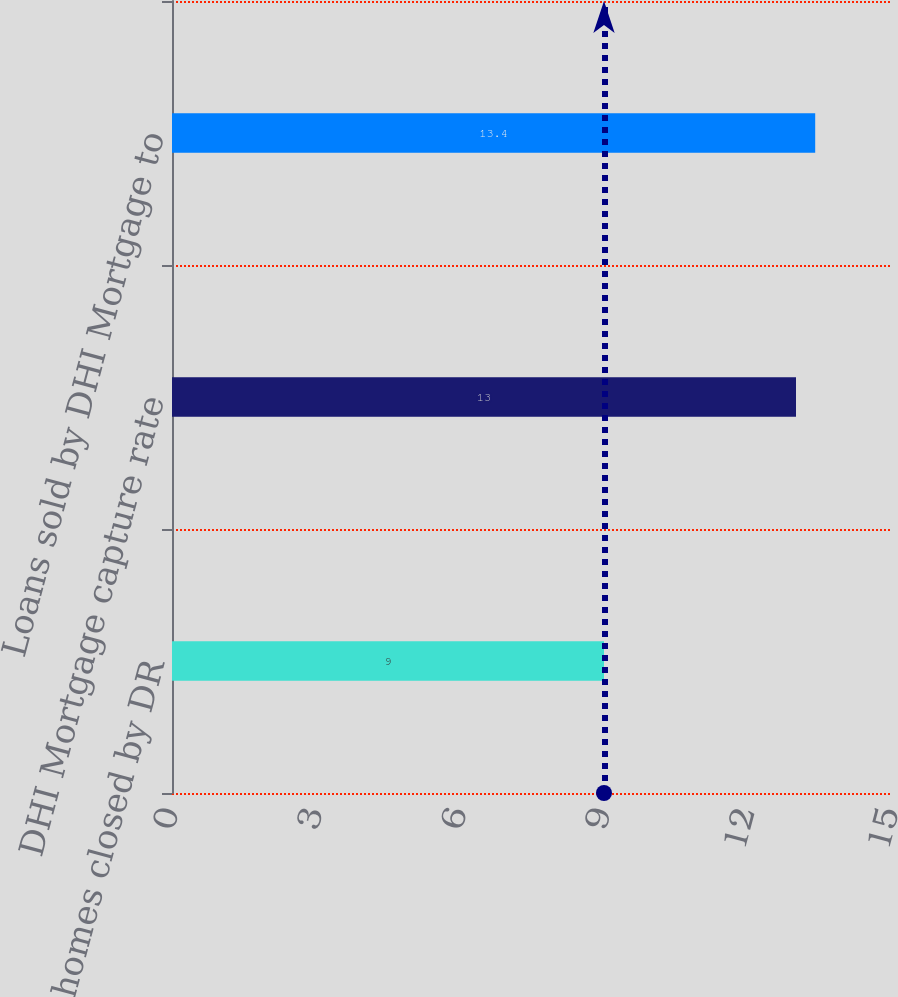Convert chart. <chart><loc_0><loc_0><loc_500><loc_500><bar_chart><fcel>Number of homes closed by DR<fcel>DHI Mortgage capture rate<fcel>Loans sold by DHI Mortgage to<nl><fcel>9<fcel>13<fcel>13.4<nl></chart> 